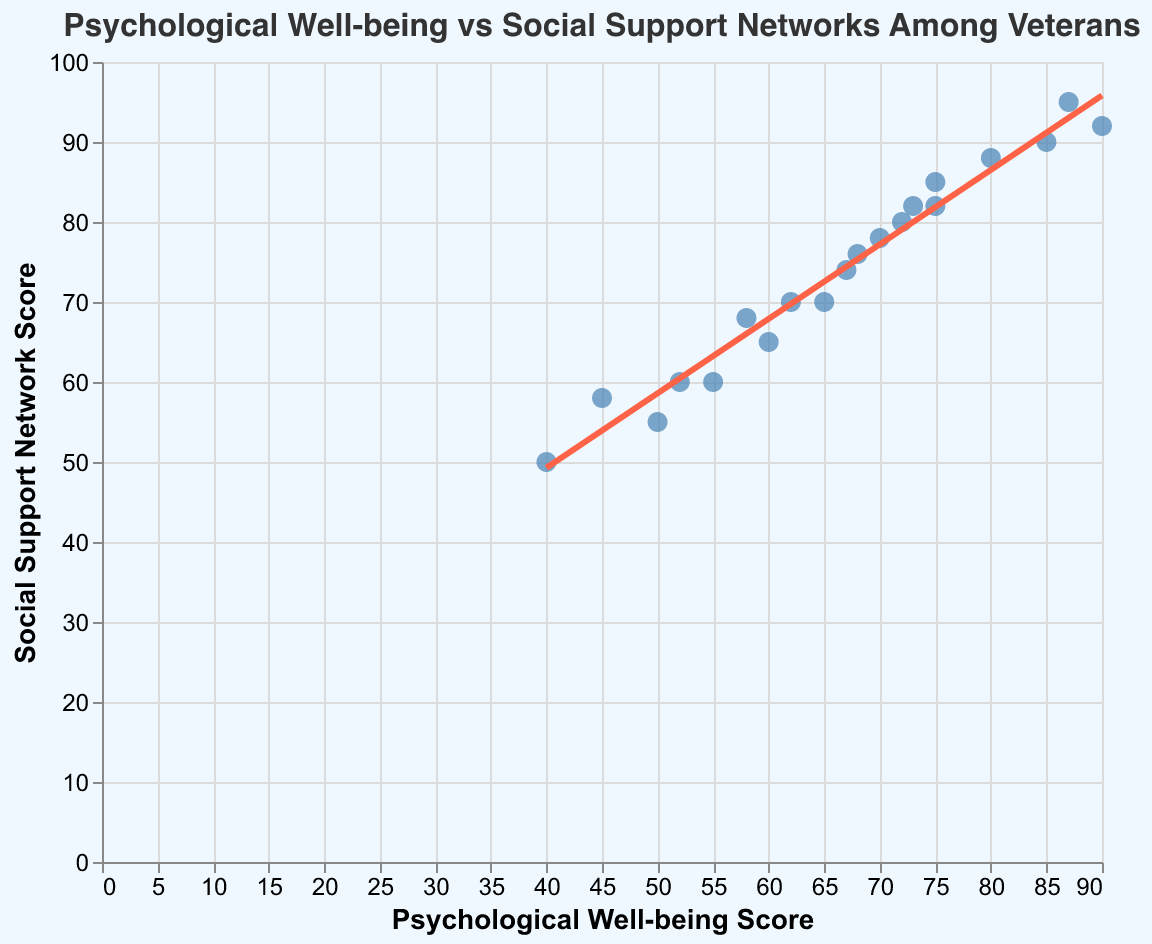What's the title of the plot? The title of the plot is displayed at the very top of the visual. It reads: "Psychological Well-being vs Social Support Networks Among Veterans."
Answer: "Psychological Well-being vs Social Support Networks Among Veterans" How many veterans reported 0 UFO sightings? To determine the number of veterans reporting 0 UFO sightings, we look at the tooltip information on the plot points. The data shows three points with 0 UFO sightings.
Answer: 3 As psychological well-being scores increase, what general trend do you observe in social support network scores? Observing the trend line within the scatter plot, as the psychological well-being scores increase, the social support network scores also show a tendency to increase.
Answer: Social support network scores increase Which veteran has the highest psychological well-being score and what is their social support network score? By observing the data points and checking the tooltip information, the veteran with the highest psychological well-being score is Veteran 9 with a psychological well-being score of 90 and a social support network score of 92.
Answer: Veteran 9 with a social support network score of 92 How do the social support network scores compare for veterans with psychological well-being scores of 75 and 85? By looking at the axis and checking the plot points, for a psychological well-being score of 75, the social support network score is approximately 85; for a score of 85, it is approximately 90.
Answer: 85 vs 90 What's the average psychological well-being score of veterans who reported 3 UFO sightings? Review the data points with 3 UFO sightings and calculate their average psychological well-being. The scores are 60, 58, and 62, which average to (60+58+62)/3 = 60.
Answer: 60 Is there a veteran who has a higher social support network score than psychological well-being score? Comparing all data points, we notice that Veteran 6 has a psychological well-being score of 80 but a higher social support network score of 88.
Answer: Yes, Veteran 6 Among veterans with more than 20 years of service, what is the range of social support network scores? Look at the veterans with more than 20 years of service (IDs 3, 5, 7, 10, 12, 13, 15, and 20) and find their social support network scores: 65, 55, 60, 50, 68, 82, 60, 58. The range is found by subtracting the smallest value from the largest: 82 - 50 = 32.
Answer: 32 Are there more veterans with a psychological well-being score above 70 or below 70? Counting the data points, there are 8 veterans with psychological well-being scores above 70 and 12 veterans with scores below 70.
Answer: Below 70 